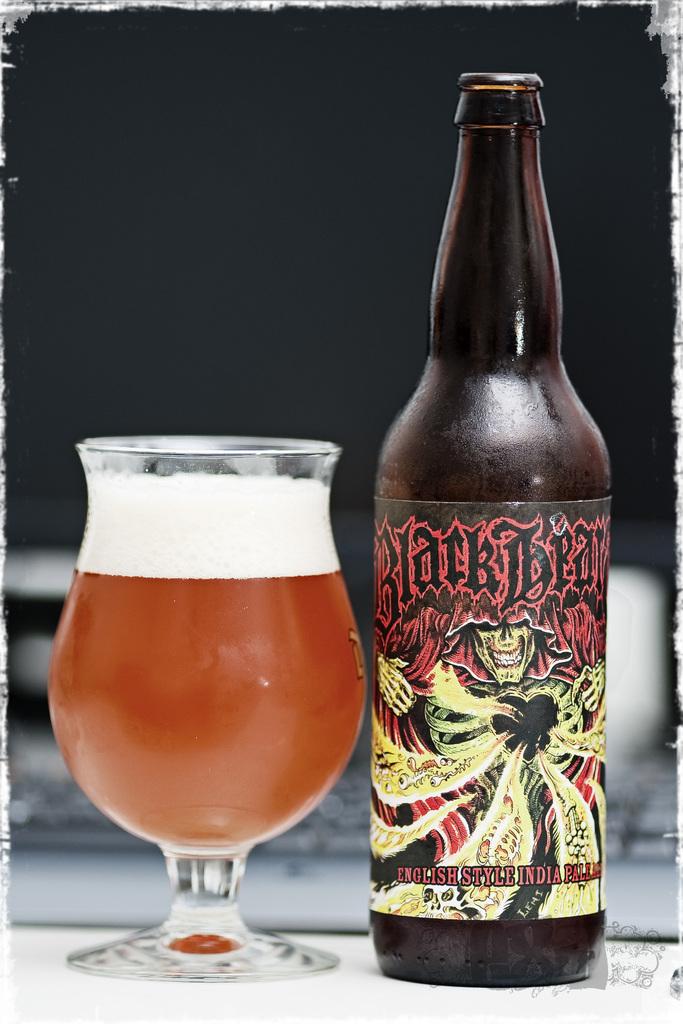What kind of beer is this?
Ensure brevity in your answer.  Blackbear. What is the name of the beer?
Your response must be concise. Black bear. 